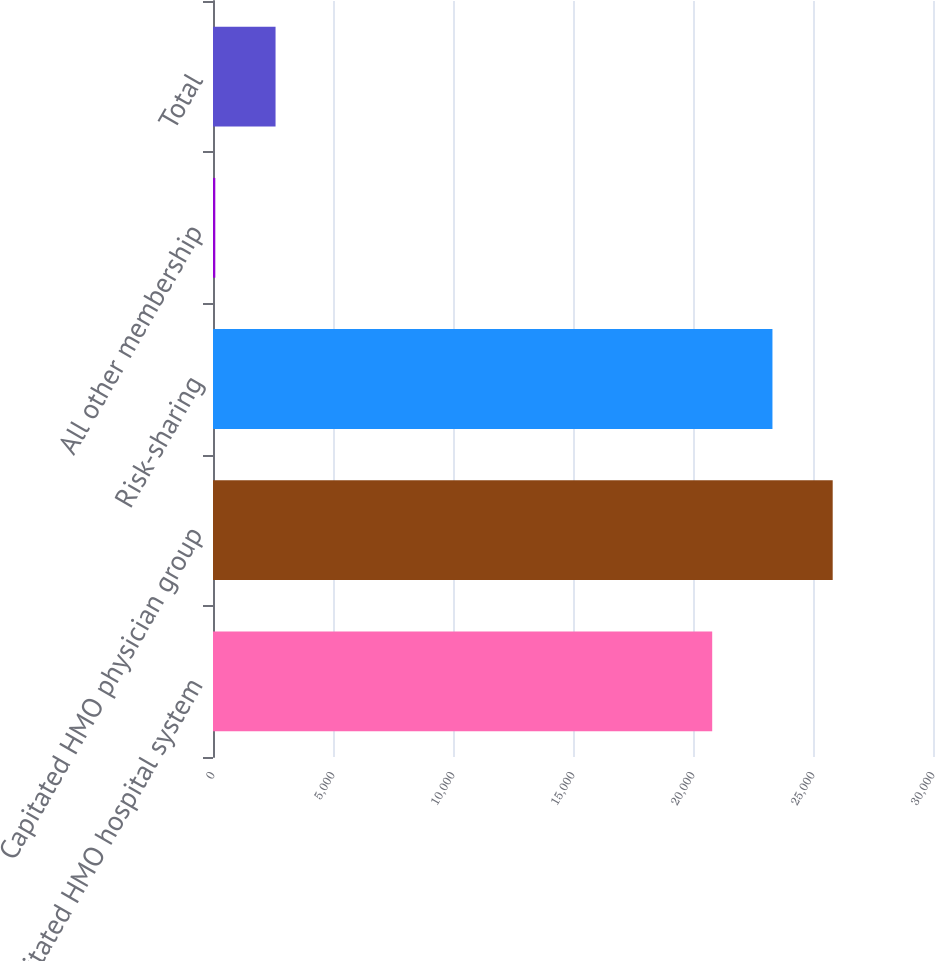Convert chart. <chart><loc_0><loc_0><loc_500><loc_500><bar_chart><fcel>Capitated HMO hospital system<fcel>Capitated HMO physician group<fcel>Risk-sharing<fcel>All other membership<fcel>Total<nl><fcel>20800<fcel>25820.8<fcel>23310.4<fcel>95.8<fcel>2606.22<nl></chart> 